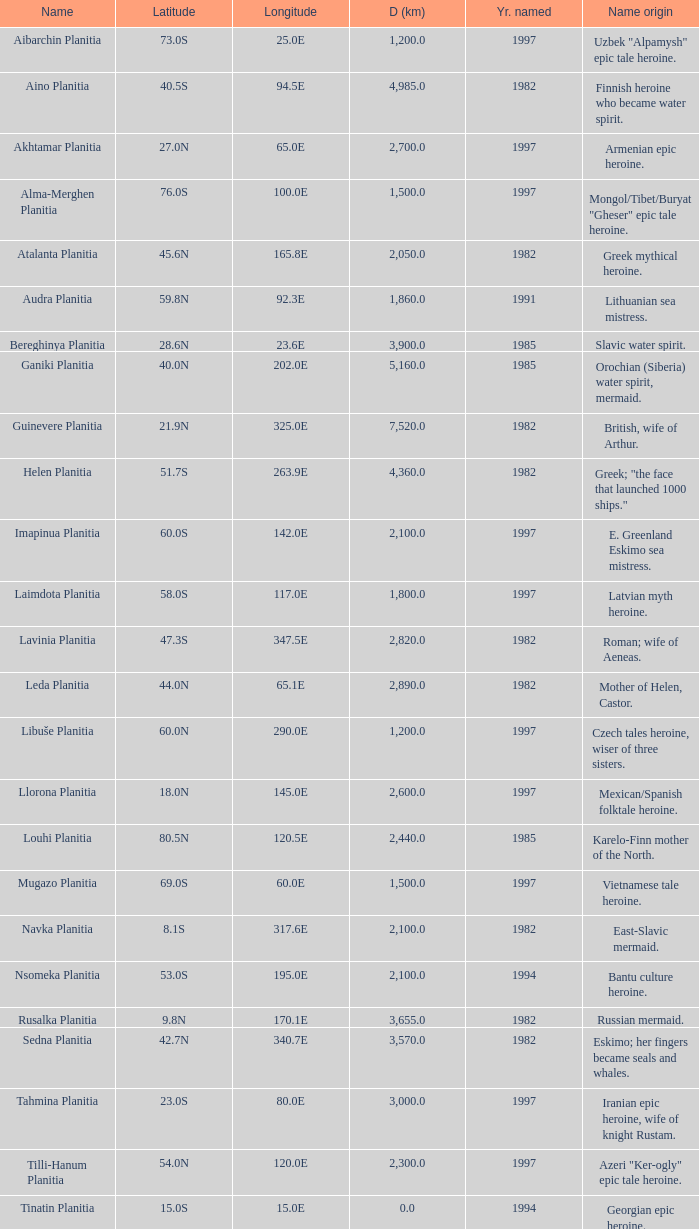What is the diameter (km) of feature of latitude 40.5s 4985.0. Can you give me this table as a dict? {'header': ['Name', 'Latitude', 'Longitude', 'D (km)', 'Yr. named', 'Name origin'], 'rows': [['Aibarchin Planitia', '73.0S', '25.0E', '1,200.0', '1997', 'Uzbek "Alpamysh" epic tale heroine.'], ['Aino Planitia', '40.5S', '94.5E', '4,985.0', '1982', 'Finnish heroine who became water spirit.'], ['Akhtamar Planitia', '27.0N', '65.0E', '2,700.0', '1997', 'Armenian epic heroine.'], ['Alma-Merghen Planitia', '76.0S', '100.0E', '1,500.0', '1997', 'Mongol/Tibet/Buryat "Gheser" epic tale heroine.'], ['Atalanta Planitia', '45.6N', '165.8E', '2,050.0', '1982', 'Greek mythical heroine.'], ['Audra Planitia', '59.8N', '92.3E', '1,860.0', '1991', 'Lithuanian sea mistress.'], ['Bereghinya Planitia', '28.6N', '23.6E', '3,900.0', '1985', 'Slavic water spirit.'], ['Ganiki Planitia', '40.0N', '202.0E', '5,160.0', '1985', 'Orochian (Siberia) water spirit, mermaid.'], ['Guinevere Planitia', '21.9N', '325.0E', '7,520.0', '1982', 'British, wife of Arthur.'], ['Helen Planitia', '51.7S', '263.9E', '4,360.0', '1982', 'Greek; "the face that launched 1000 ships."'], ['Imapinua Planitia', '60.0S', '142.0E', '2,100.0', '1997', 'E. Greenland Eskimo sea mistress.'], ['Laimdota Planitia', '58.0S', '117.0E', '1,800.0', '1997', 'Latvian myth heroine.'], ['Lavinia Planitia', '47.3S', '347.5E', '2,820.0', '1982', 'Roman; wife of Aeneas.'], ['Leda Planitia', '44.0N', '65.1E', '2,890.0', '1982', 'Mother of Helen, Castor.'], ['Libuše Planitia', '60.0N', '290.0E', '1,200.0', '1997', 'Czech tales heroine, wiser of three sisters.'], ['Llorona Planitia', '18.0N', '145.0E', '2,600.0', '1997', 'Mexican/Spanish folktale heroine.'], ['Louhi Planitia', '80.5N', '120.5E', '2,440.0', '1985', 'Karelo-Finn mother of the North.'], ['Mugazo Planitia', '69.0S', '60.0E', '1,500.0', '1997', 'Vietnamese tale heroine.'], ['Navka Planitia', '8.1S', '317.6E', '2,100.0', '1982', 'East-Slavic mermaid.'], ['Nsomeka Planitia', '53.0S', '195.0E', '2,100.0', '1994', 'Bantu culture heroine.'], ['Rusalka Planitia', '9.8N', '170.1E', '3,655.0', '1982', 'Russian mermaid.'], ['Sedna Planitia', '42.7N', '340.7E', '3,570.0', '1982', 'Eskimo; her fingers became seals and whales.'], ['Tahmina Planitia', '23.0S', '80.0E', '3,000.0', '1997', 'Iranian epic heroine, wife of knight Rustam.'], ['Tilli-Hanum Planitia', '54.0N', '120.0E', '2,300.0', '1997', 'Azeri "Ker-ogly" epic tale heroine.'], ['Tinatin Planitia', '15.0S', '15.0E', '0.0', '1994', 'Georgian epic heroine.'], ['Undine Planitia', '13.0N', '303.0E', '2,800.0', '1997', 'Lithuanian water nymph, mermaid.'], ['Vellamo Planitia', '45.4N', '149.1E', '2,155.0', '1985', 'Karelo-Finn mermaid.']]} 